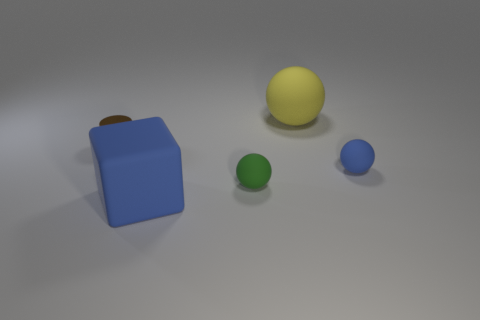Add 4 tiny gray metal cylinders. How many objects exist? 9 Subtract all spheres. How many objects are left? 2 Subtract all blue rubber blocks. Subtract all tiny blue spheres. How many objects are left? 3 Add 5 brown metal cylinders. How many brown metal cylinders are left? 6 Add 4 small blue objects. How many small blue objects exist? 5 Subtract 1 blue cubes. How many objects are left? 4 